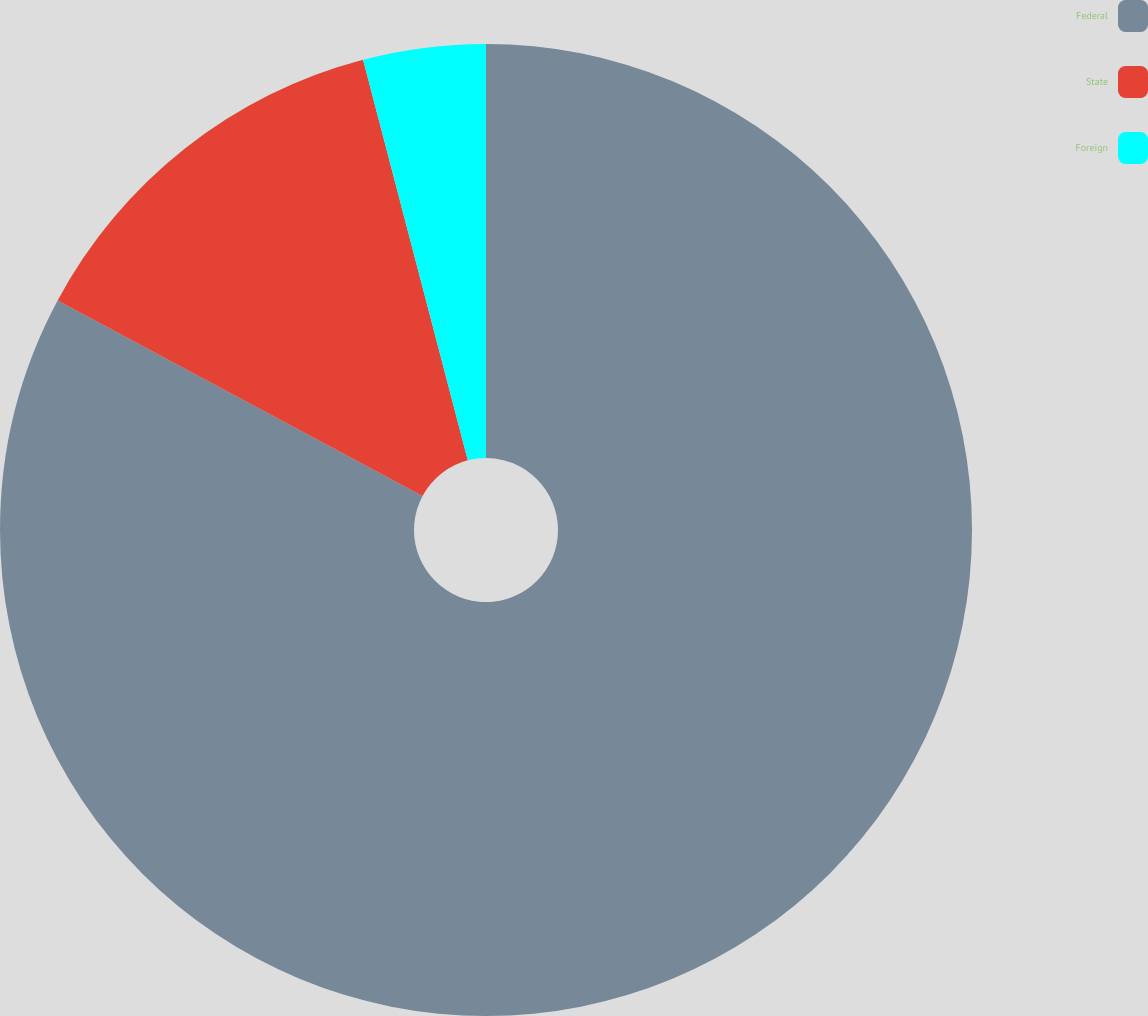<chart> <loc_0><loc_0><loc_500><loc_500><pie_chart><fcel>Federal<fcel>State<fcel>Foreign<nl><fcel>82.83%<fcel>13.1%<fcel>4.07%<nl></chart> 